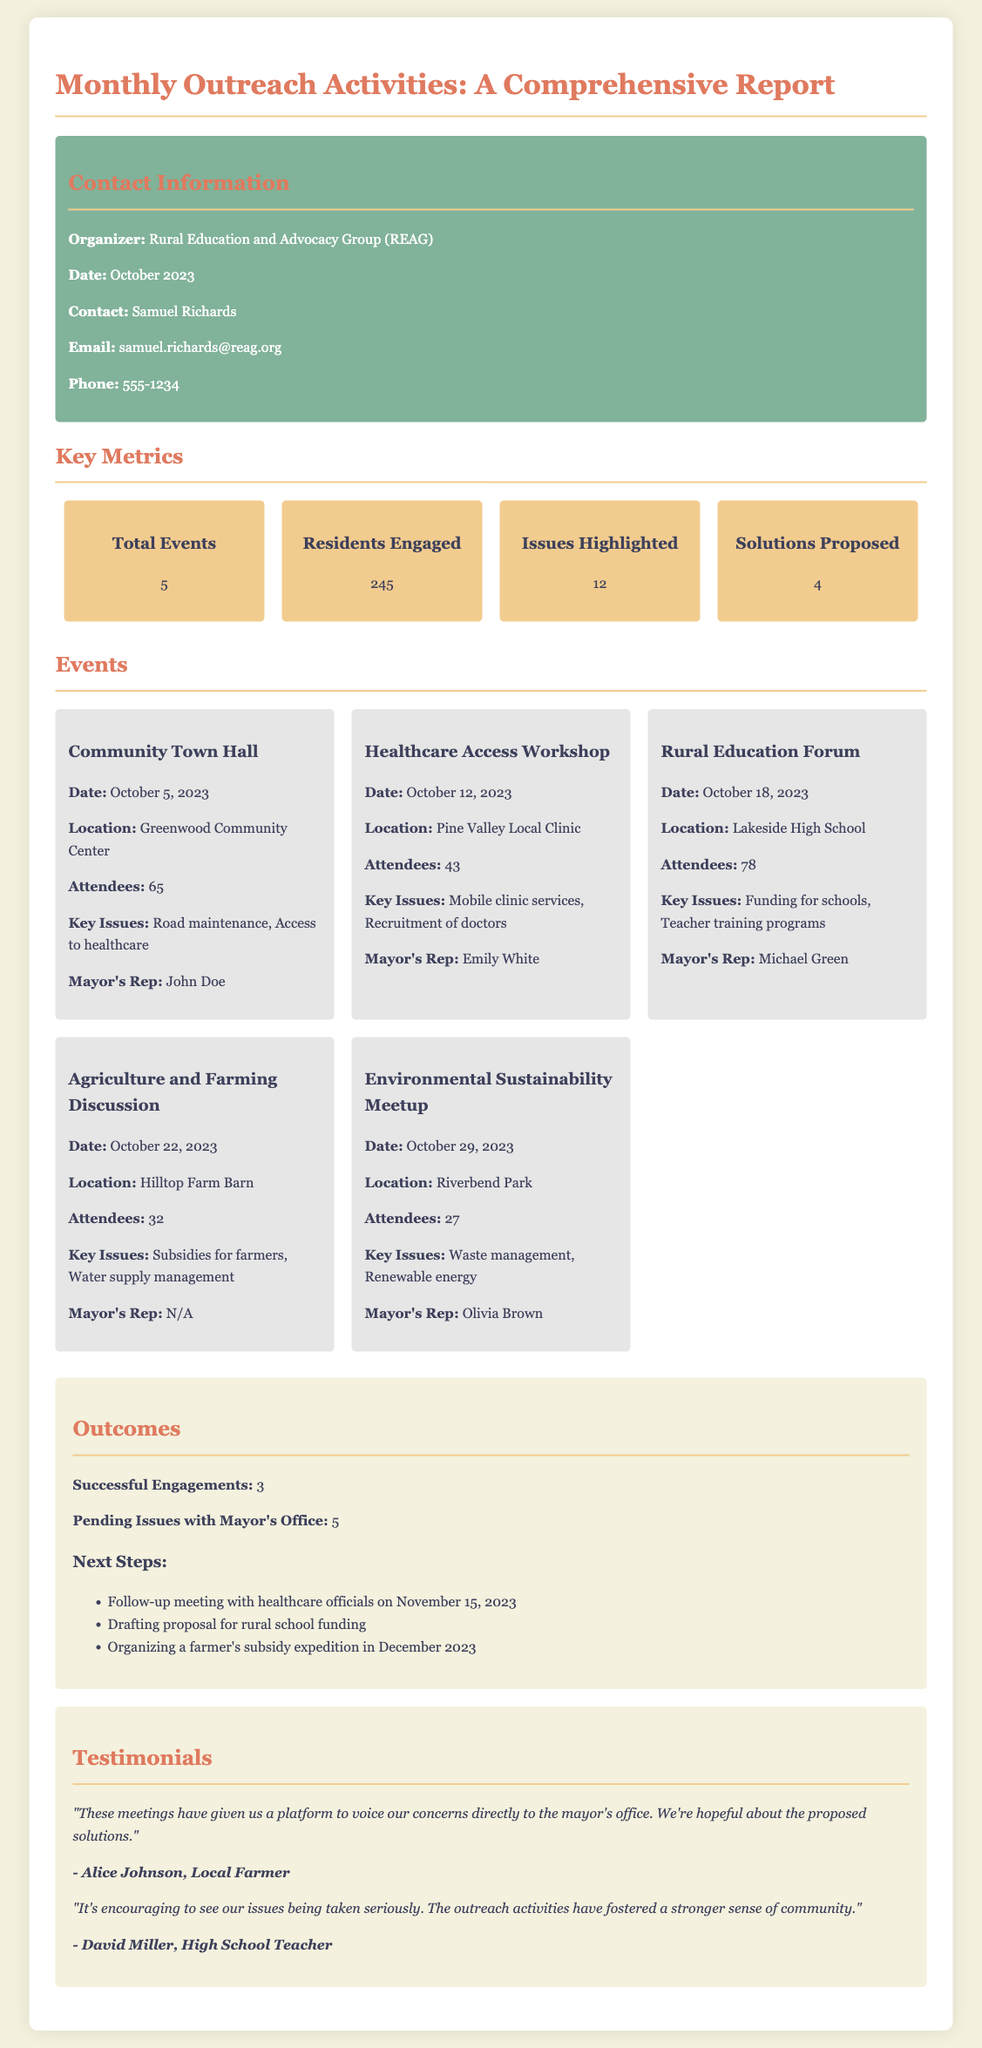What organization is responsible for the outreach activities? The document states that the organizer of the outreach activities is the Rural Education and Advocacy Group (REAG).
Answer: Rural Education and Advocacy Group (REAG) How many residents were engaged during the outreach activities? The total number of residents engaged is a key metric presented in the document.
Answer: 245 What date was the Community Town Hall held? The specific date for the Community Town Hall event is provided in the events section of the document.
Answer: October 5, 2023 Which issue was highlighted during the Healthcare Access Workshop? The key issues highlighted in each event are listed, and one is the mobile clinic services for this workshop.
Answer: Mobile clinic services How many outcomes are classified as successful engagements? The outcomes section mentions a specific number of successful engagements, labeled in the text.
Answer: 3 What is the next step planned after the meetings? The document lists specific next steps, including a follow-up meeting with healthcare officials.
Answer: Follow-up meeting with healthcare officials on November 15, 2023 What is the location of the Environmental Sustainability Meetup? The location of each event is detailed, and for this event, it's stated clearly.
Answer: Riverbend Park Who represented the mayor at the Agriculture and Farming Discussion? The document notes which representatives attended each event, and this event had no representative listed.
Answer: N/A What issue did Alice Johnson mention in her testimonial? The testimonials provide quotes that reflect concerns or benefits from the meetings, where Alice Johnson addresses the platform given for voicing concerns.
Answer: Voicing concerns directly to the mayor's office 